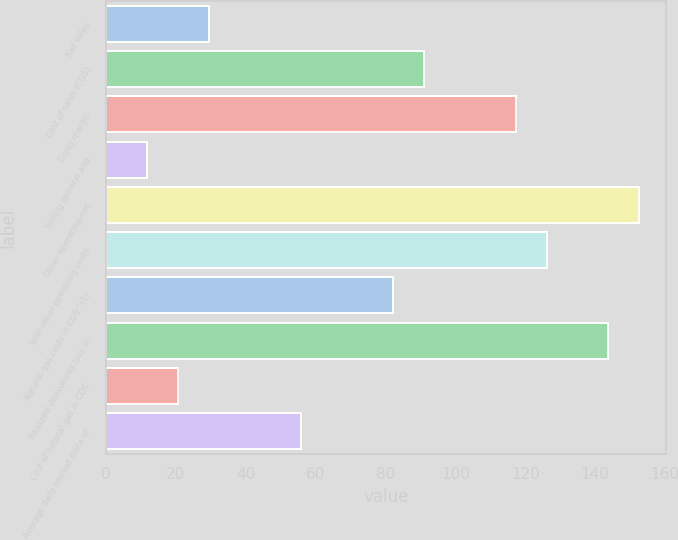Convert chart. <chart><loc_0><loc_0><loc_500><loc_500><bar_chart><fcel>Net sales<fcel>Cost of sales (COS)<fcel>Gross margin<fcel>Selling general and<fcel>Other operating-net<fcel>Total other operating costs<fcel>Natural gas costs in COS^(1)<fcel>Realized derivatives loss in<fcel>Cost of natural gas in COS<fcel>Average daily market price of<nl><fcel>29.4<fcel>91<fcel>117.4<fcel>11.8<fcel>152.6<fcel>126.2<fcel>82.2<fcel>143.8<fcel>20.6<fcel>55.8<nl></chart> 